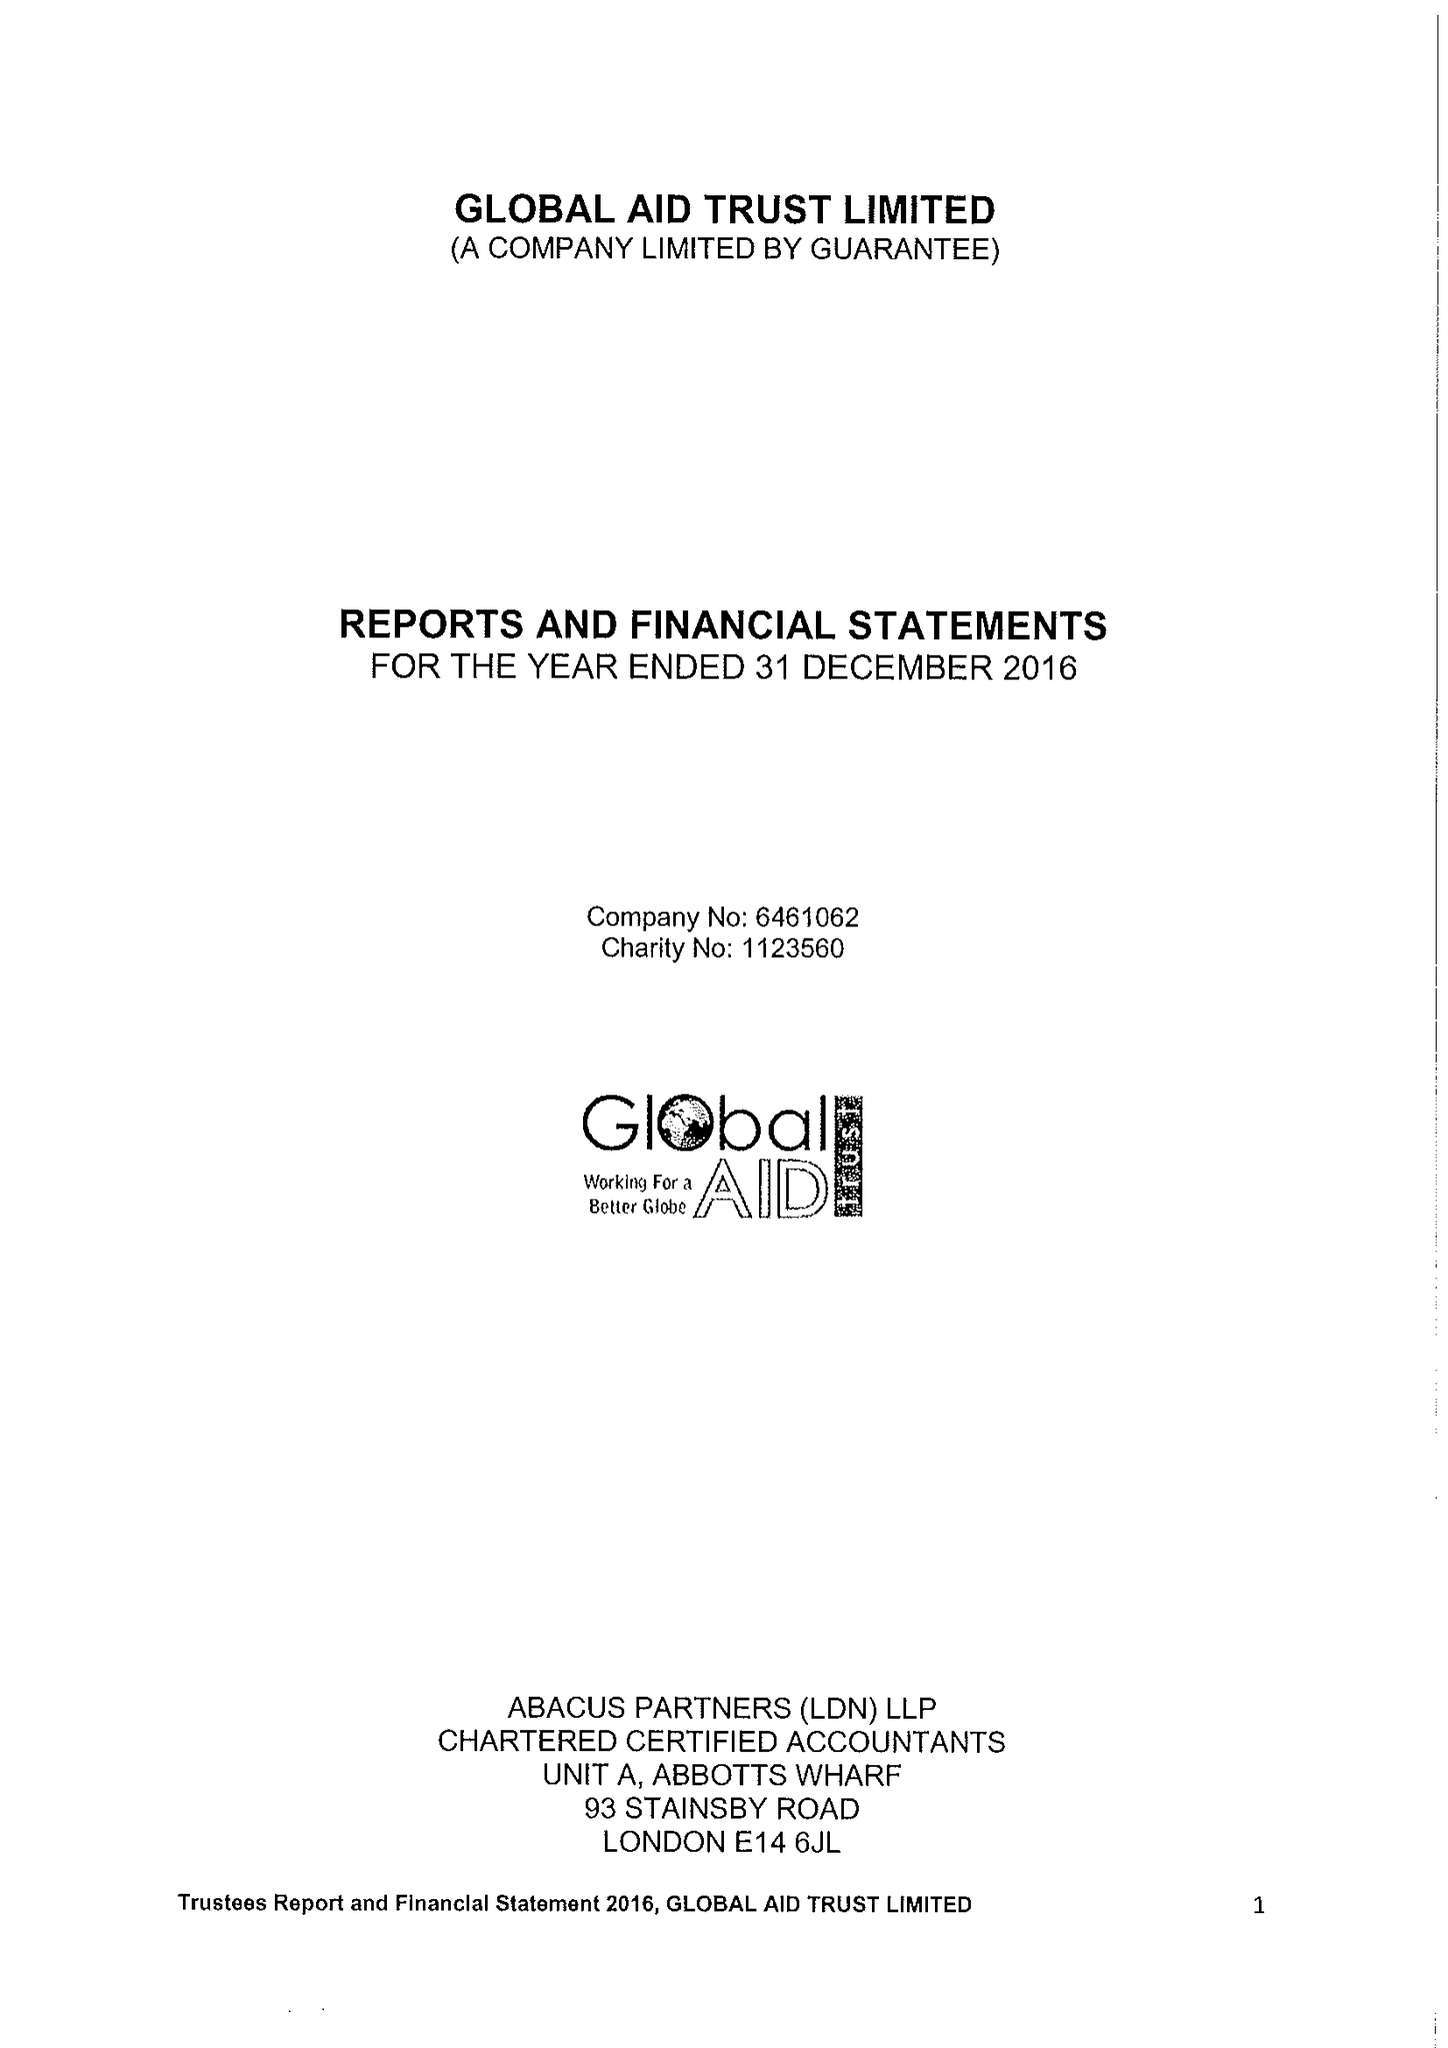What is the value for the spending_annually_in_british_pounds?
Answer the question using a single word or phrase. 219254.00 